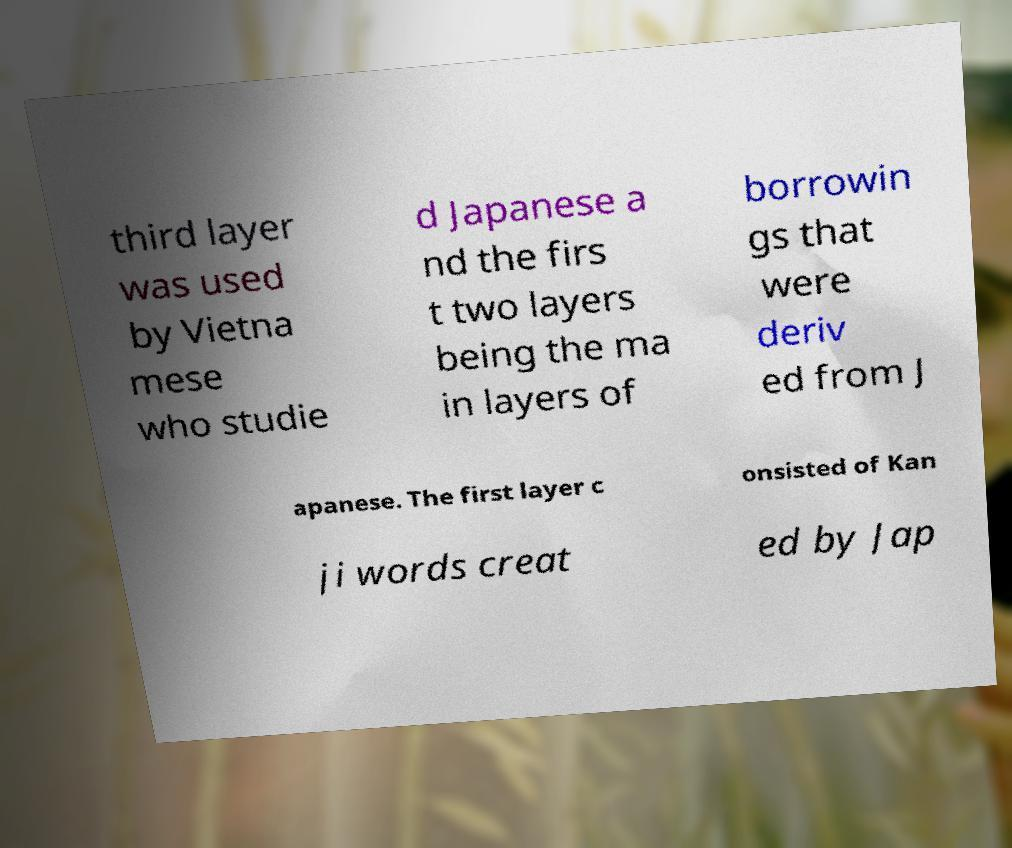What messages or text are displayed in this image? I need them in a readable, typed format. third layer was used by Vietna mese who studie d Japanese a nd the firs t two layers being the ma in layers of borrowin gs that were deriv ed from J apanese. The first layer c onsisted of Kan ji words creat ed by Jap 